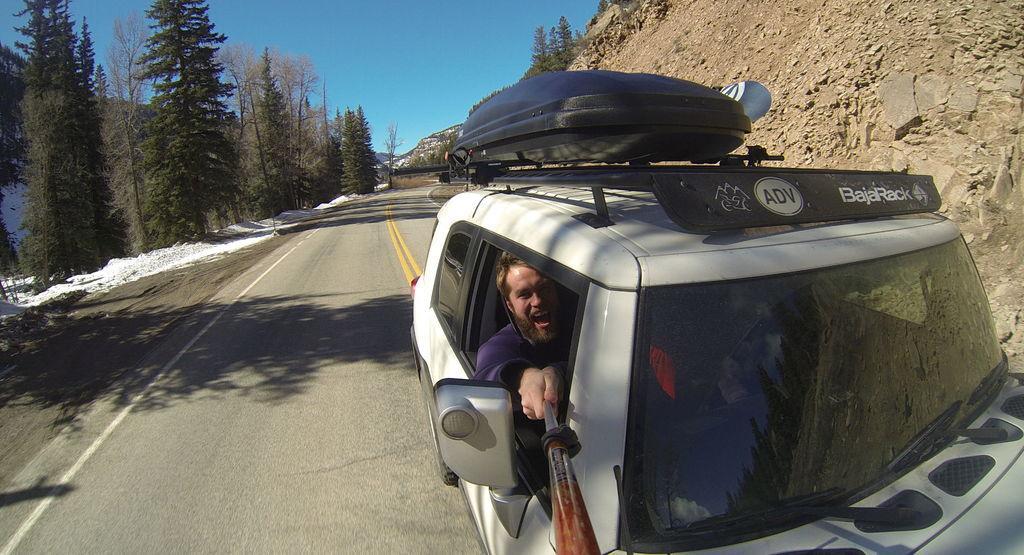In one or two sentences, can you explain what this image depicts? In the middle right bottom of the image, there is a car, in which a person is sitting and riding a car. In the right top, there is a mountain. In the left side of the image, there are trees visible. On the top most sky blue color visible. In the middle of the image, a road is visible. This image is taken during day time on the road. 